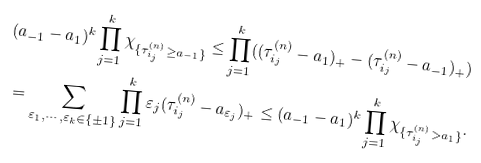<formula> <loc_0><loc_0><loc_500><loc_500>( a _ { - 1 } - a _ { 1 } ) ^ { k } \prod _ { j = 1 } ^ { k } \chi _ { \{ \tau ^ { ( n ) } _ { i _ { j } } \geq a _ { - 1 } \} } \leq \prod _ { j = 1 } ^ { k } ( ( \tau ^ { ( n ) } _ { i _ { j } } - a _ { 1 } ) _ { + } - ( \tau ^ { ( n ) } _ { i _ { j } } - a _ { - 1 } ) _ { + } ) \\ = \sum _ { \varepsilon _ { 1 } , \cdots , \varepsilon _ { k } \in \{ \pm 1 \} } \prod _ { j = 1 } ^ { k } \varepsilon _ { j } ( \tau ^ { ( n ) } _ { i _ { j } } - a _ { \varepsilon _ { j } } ) _ { + } \leq ( a _ { - 1 } - a _ { 1 } ) ^ { k } \prod _ { j = 1 } ^ { k } \chi _ { \{ \tau ^ { ( n ) } _ { i _ { j } } > a _ { 1 } \} } .</formula> 